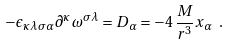Convert formula to latex. <formula><loc_0><loc_0><loc_500><loc_500>- \epsilon _ { \kappa \lambda \sigma \alpha } \partial ^ { \kappa } \omega ^ { \sigma \lambda } = D _ { \alpha } = - 4 \, \frac { M } { r ^ { 3 } } x _ { \alpha } \ .</formula> 